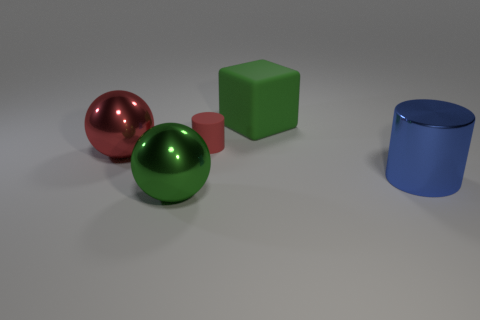Add 1 small brown blocks. How many objects exist? 6 Subtract all spheres. How many objects are left? 3 Subtract all tiny blue matte blocks. Subtract all tiny red cylinders. How many objects are left? 4 Add 4 cylinders. How many cylinders are left? 6 Add 2 large green rubber things. How many large green rubber things exist? 3 Subtract 0 gray cubes. How many objects are left? 5 